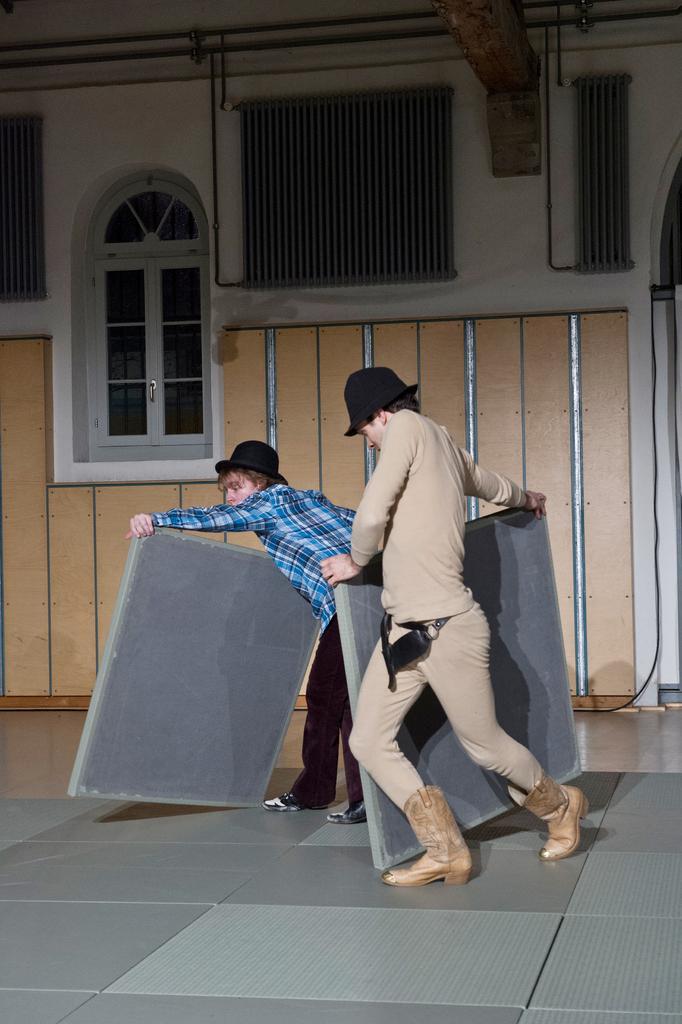In one or two sentences, can you explain what this image depicts? In this image I can see a person wearing grey colored dress and black colored hat and another person wearing blue colored shirt and black colored hat are standing and holding objects in their hands. In the background I can see the building which is white and cream in color and the window. 